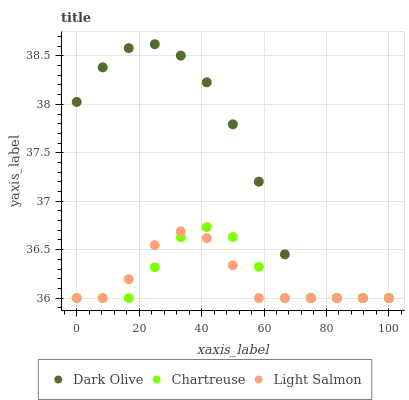Does Light Salmon have the minimum area under the curve?
Answer yes or no. Yes. Does Dark Olive have the maximum area under the curve?
Answer yes or no. Yes. Does Dark Olive have the minimum area under the curve?
Answer yes or no. No. Does Light Salmon have the maximum area under the curve?
Answer yes or no. No. Is Chartreuse the smoothest?
Answer yes or no. Yes. Is Dark Olive the roughest?
Answer yes or no. Yes. Is Light Salmon the smoothest?
Answer yes or no. No. Is Light Salmon the roughest?
Answer yes or no. No. Does Chartreuse have the lowest value?
Answer yes or no. Yes. Does Dark Olive have the highest value?
Answer yes or no. Yes. Does Light Salmon have the highest value?
Answer yes or no. No. Does Dark Olive intersect Chartreuse?
Answer yes or no. Yes. Is Dark Olive less than Chartreuse?
Answer yes or no. No. Is Dark Olive greater than Chartreuse?
Answer yes or no. No. 